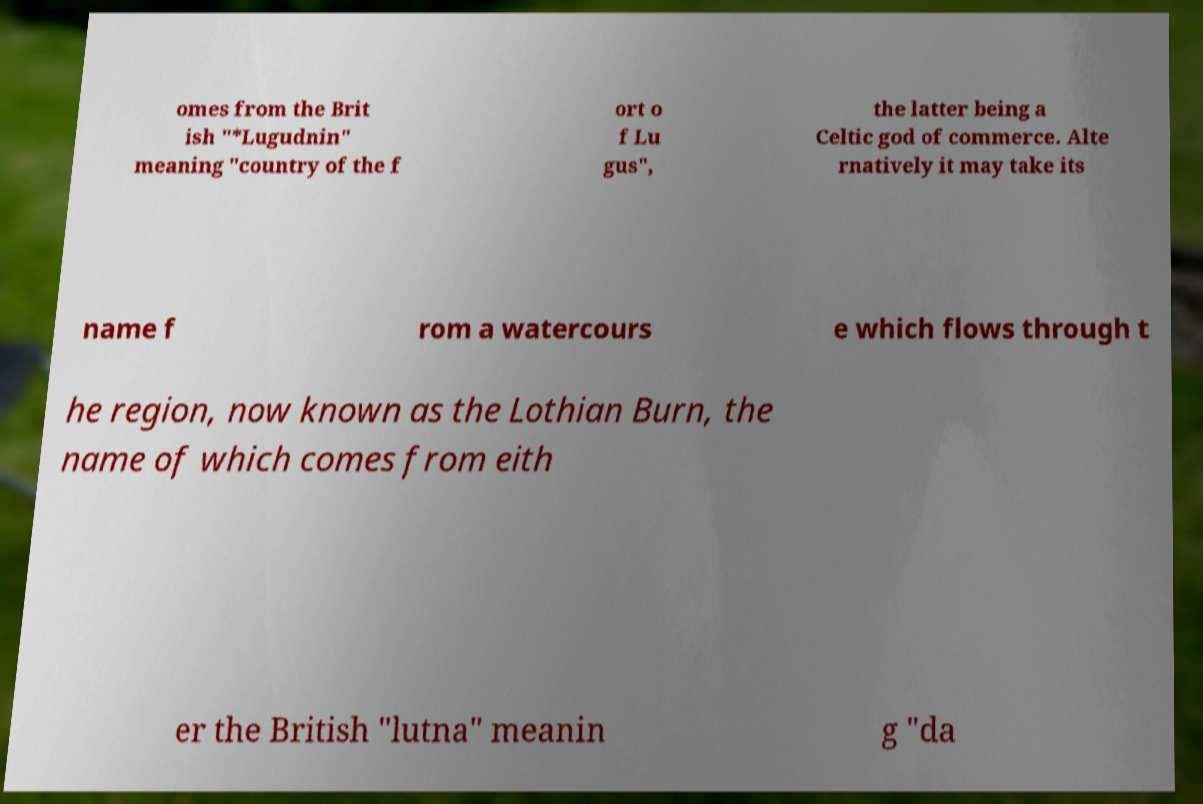Can you read and provide the text displayed in the image?This photo seems to have some interesting text. Can you extract and type it out for me? omes from the Brit ish "*Lugudnin" meaning "country of the f ort o f Lu gus", the latter being a Celtic god of commerce. Alte rnatively it may take its name f rom a watercours e which flows through t he region, now known as the Lothian Burn, the name of which comes from eith er the British "lutna" meanin g "da 